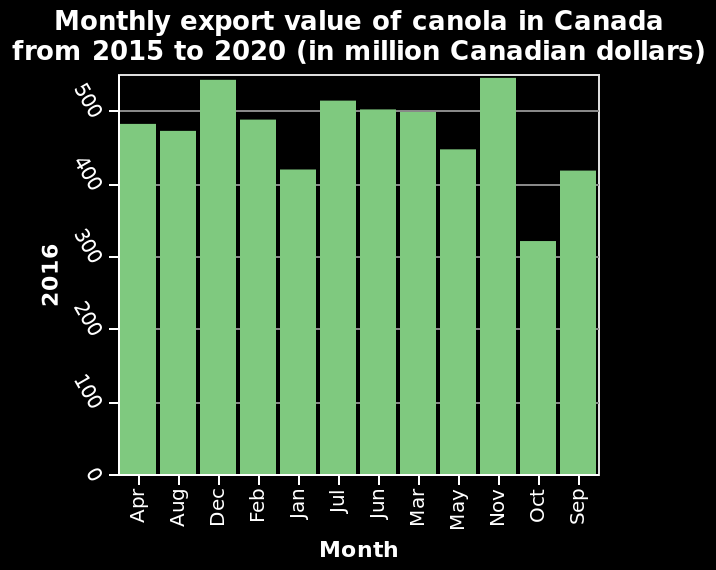<image>
please summary the statistics and relations of the chart the export value of canola has been greater than 300m CAD$ per month throughtout 2016. please enumerates aspects of the construction of the chart Monthly export value of canola in Canada from 2015 to 2020 (in million Canadian dollars) is a bar chart. A categorical scale with Apr on one end and Sep at the other can be found on the x-axis, labeled Month. Along the y-axis, 2016 is plotted with a linear scale of range 0 to 500. What was the lowest monthly export value of canola in Canada in 2016?  The lowest monthly export value of canola in Canada in 2016 was 320 million Canadian dollars in October. 